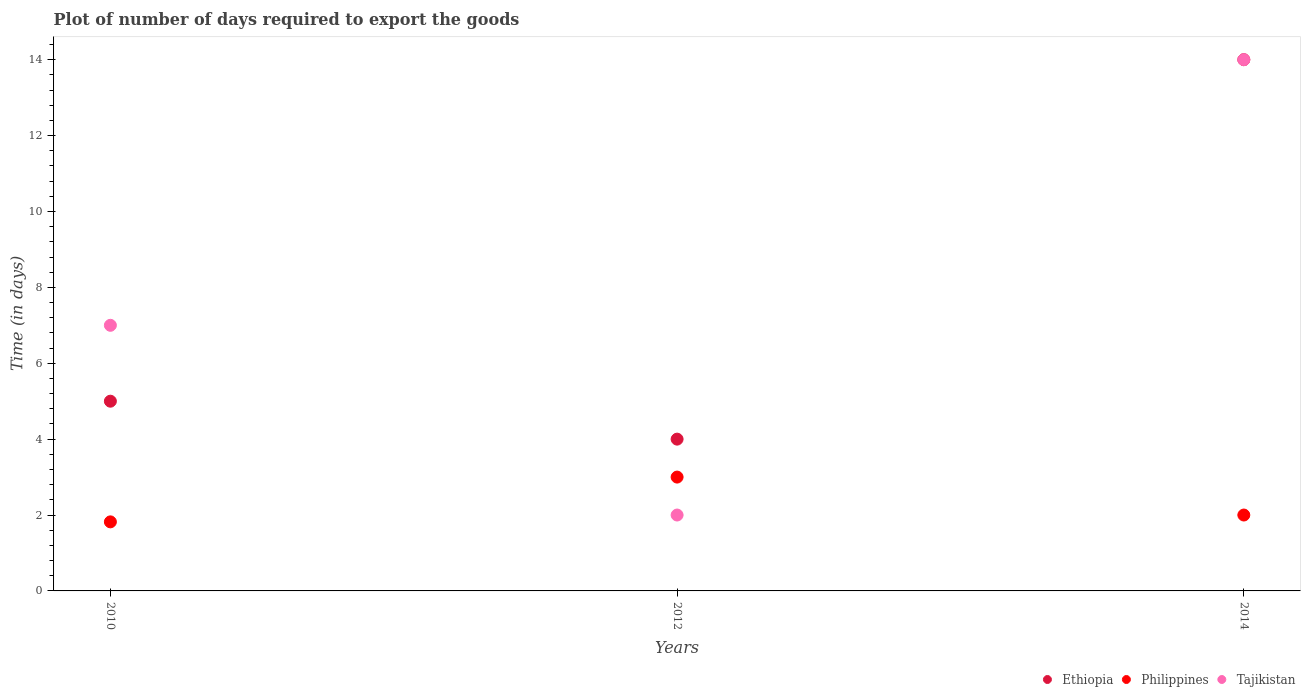Across all years, what is the maximum time required to export goods in Ethiopia?
Keep it short and to the point. 14. In which year was the time required to export goods in Ethiopia maximum?
Ensure brevity in your answer.  2014. What is the total time required to export goods in Philippines in the graph?
Your response must be concise. 6.82. What is the difference between the time required to export goods in Philippines in 2010 and that in 2014?
Provide a short and direct response. -0.18. What is the average time required to export goods in Ethiopia per year?
Your response must be concise. 7.67. Is the time required to export goods in Tajikistan in 2012 less than that in 2014?
Offer a very short reply. Yes. Is the difference between the time required to export goods in Tajikistan in 2012 and 2014 greater than the difference between the time required to export goods in Philippines in 2012 and 2014?
Offer a very short reply. No. What is the difference between the highest and the lowest time required to export goods in Tajikistan?
Provide a succinct answer. 12. In how many years, is the time required to export goods in Tajikistan greater than the average time required to export goods in Tajikistan taken over all years?
Your response must be concise. 1. Is the time required to export goods in Tajikistan strictly greater than the time required to export goods in Ethiopia over the years?
Provide a short and direct response. No. How many dotlines are there?
Ensure brevity in your answer.  3. How many years are there in the graph?
Provide a succinct answer. 3. Are the values on the major ticks of Y-axis written in scientific E-notation?
Ensure brevity in your answer.  No. Where does the legend appear in the graph?
Offer a very short reply. Bottom right. What is the title of the graph?
Offer a very short reply. Plot of number of days required to export the goods. What is the label or title of the Y-axis?
Your answer should be compact. Time (in days). What is the Time (in days) in Philippines in 2010?
Keep it short and to the point. 1.82. What is the Time (in days) of Philippines in 2012?
Your answer should be compact. 3. What is the Time (in days) in Tajikistan in 2012?
Keep it short and to the point. 2. What is the Time (in days) in Ethiopia in 2014?
Give a very brief answer. 14. What is the Time (in days) of Tajikistan in 2014?
Provide a short and direct response. 14. Across all years, what is the maximum Time (in days) in Tajikistan?
Provide a short and direct response. 14. Across all years, what is the minimum Time (in days) in Ethiopia?
Make the answer very short. 4. Across all years, what is the minimum Time (in days) in Philippines?
Ensure brevity in your answer.  1.82. What is the total Time (in days) of Philippines in the graph?
Provide a short and direct response. 6.82. What is the difference between the Time (in days) of Ethiopia in 2010 and that in 2012?
Offer a terse response. 1. What is the difference between the Time (in days) of Philippines in 2010 and that in 2012?
Offer a very short reply. -1.18. What is the difference between the Time (in days) of Tajikistan in 2010 and that in 2012?
Your answer should be compact. 5. What is the difference between the Time (in days) in Philippines in 2010 and that in 2014?
Offer a very short reply. -0.18. What is the difference between the Time (in days) of Tajikistan in 2010 and that in 2014?
Offer a terse response. -7. What is the difference between the Time (in days) in Philippines in 2012 and that in 2014?
Provide a short and direct response. 1. What is the difference between the Time (in days) in Ethiopia in 2010 and the Time (in days) in Philippines in 2012?
Provide a succinct answer. 2. What is the difference between the Time (in days) in Philippines in 2010 and the Time (in days) in Tajikistan in 2012?
Make the answer very short. -0.18. What is the difference between the Time (in days) in Ethiopia in 2010 and the Time (in days) in Philippines in 2014?
Offer a very short reply. 3. What is the difference between the Time (in days) of Philippines in 2010 and the Time (in days) of Tajikistan in 2014?
Offer a very short reply. -12.18. What is the difference between the Time (in days) in Philippines in 2012 and the Time (in days) in Tajikistan in 2014?
Offer a terse response. -11. What is the average Time (in days) of Ethiopia per year?
Provide a short and direct response. 7.67. What is the average Time (in days) of Philippines per year?
Give a very brief answer. 2.27. What is the average Time (in days) of Tajikistan per year?
Provide a short and direct response. 7.67. In the year 2010, what is the difference between the Time (in days) of Ethiopia and Time (in days) of Philippines?
Your answer should be very brief. 3.18. In the year 2010, what is the difference between the Time (in days) in Philippines and Time (in days) in Tajikistan?
Provide a succinct answer. -5.18. In the year 2014, what is the difference between the Time (in days) in Ethiopia and Time (in days) in Philippines?
Make the answer very short. 12. What is the ratio of the Time (in days) of Ethiopia in 2010 to that in 2012?
Make the answer very short. 1.25. What is the ratio of the Time (in days) in Philippines in 2010 to that in 2012?
Make the answer very short. 0.61. What is the ratio of the Time (in days) in Tajikistan in 2010 to that in 2012?
Provide a short and direct response. 3.5. What is the ratio of the Time (in days) in Ethiopia in 2010 to that in 2014?
Your answer should be compact. 0.36. What is the ratio of the Time (in days) of Philippines in 2010 to that in 2014?
Provide a short and direct response. 0.91. What is the ratio of the Time (in days) of Ethiopia in 2012 to that in 2014?
Give a very brief answer. 0.29. What is the ratio of the Time (in days) in Tajikistan in 2012 to that in 2014?
Offer a terse response. 0.14. What is the difference between the highest and the second highest Time (in days) of Philippines?
Keep it short and to the point. 1. What is the difference between the highest and the second highest Time (in days) of Tajikistan?
Ensure brevity in your answer.  7. What is the difference between the highest and the lowest Time (in days) of Philippines?
Provide a succinct answer. 1.18. What is the difference between the highest and the lowest Time (in days) in Tajikistan?
Make the answer very short. 12. 